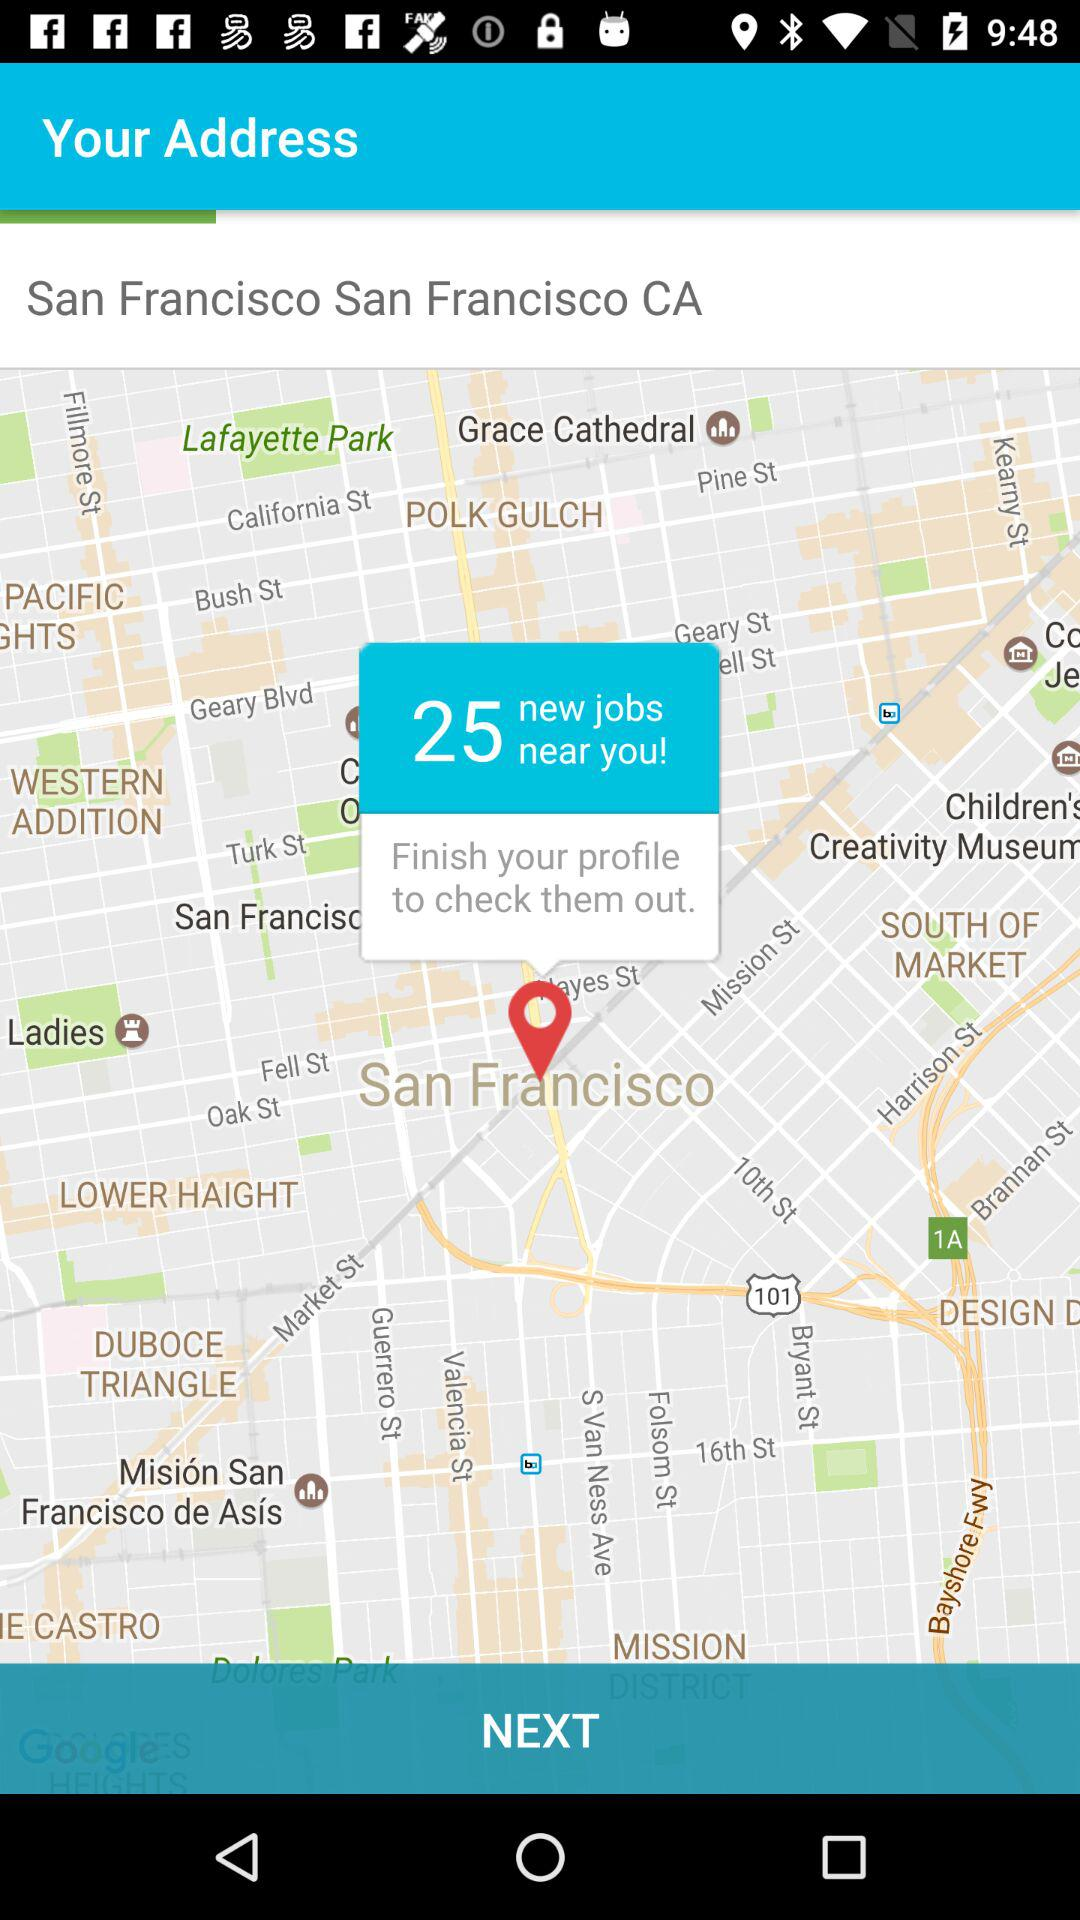How many new jobs are nearby? There are 25 new jobs nearby. 